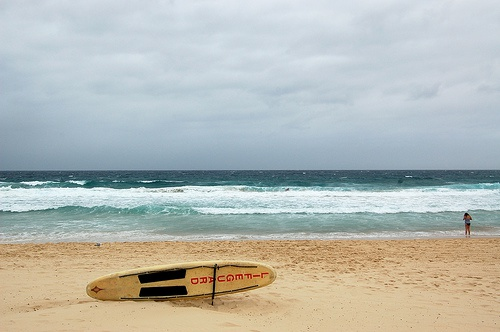Describe the objects in this image and their specific colors. I can see surfboard in lightgray, tan, black, and olive tones and people in lightgray, maroon, gray, and black tones in this image. 